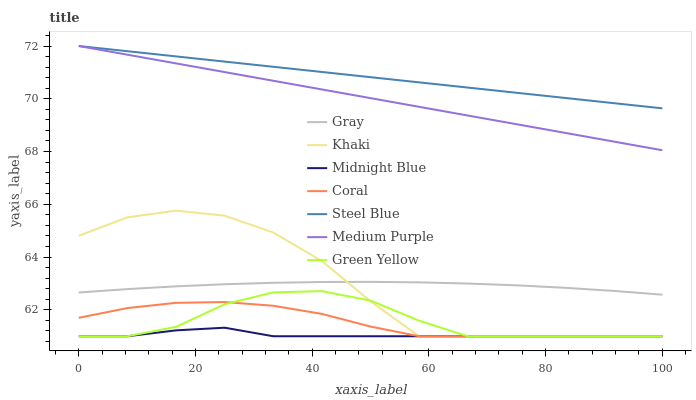Does Midnight Blue have the minimum area under the curve?
Answer yes or no. Yes. Does Steel Blue have the maximum area under the curve?
Answer yes or no. Yes. Does Khaki have the minimum area under the curve?
Answer yes or no. No. Does Khaki have the maximum area under the curve?
Answer yes or no. No. Is Steel Blue the smoothest?
Answer yes or no. Yes. Is Khaki the roughest?
Answer yes or no. Yes. Is Midnight Blue the smoothest?
Answer yes or no. No. Is Midnight Blue the roughest?
Answer yes or no. No. Does Steel Blue have the lowest value?
Answer yes or no. No. Does Medium Purple have the highest value?
Answer yes or no. Yes. Does Khaki have the highest value?
Answer yes or no. No. Is Khaki less than Medium Purple?
Answer yes or no. Yes. Is Medium Purple greater than Khaki?
Answer yes or no. Yes. Does Steel Blue intersect Medium Purple?
Answer yes or no. Yes. Is Steel Blue less than Medium Purple?
Answer yes or no. No. Is Steel Blue greater than Medium Purple?
Answer yes or no. No. Does Khaki intersect Medium Purple?
Answer yes or no. No. 